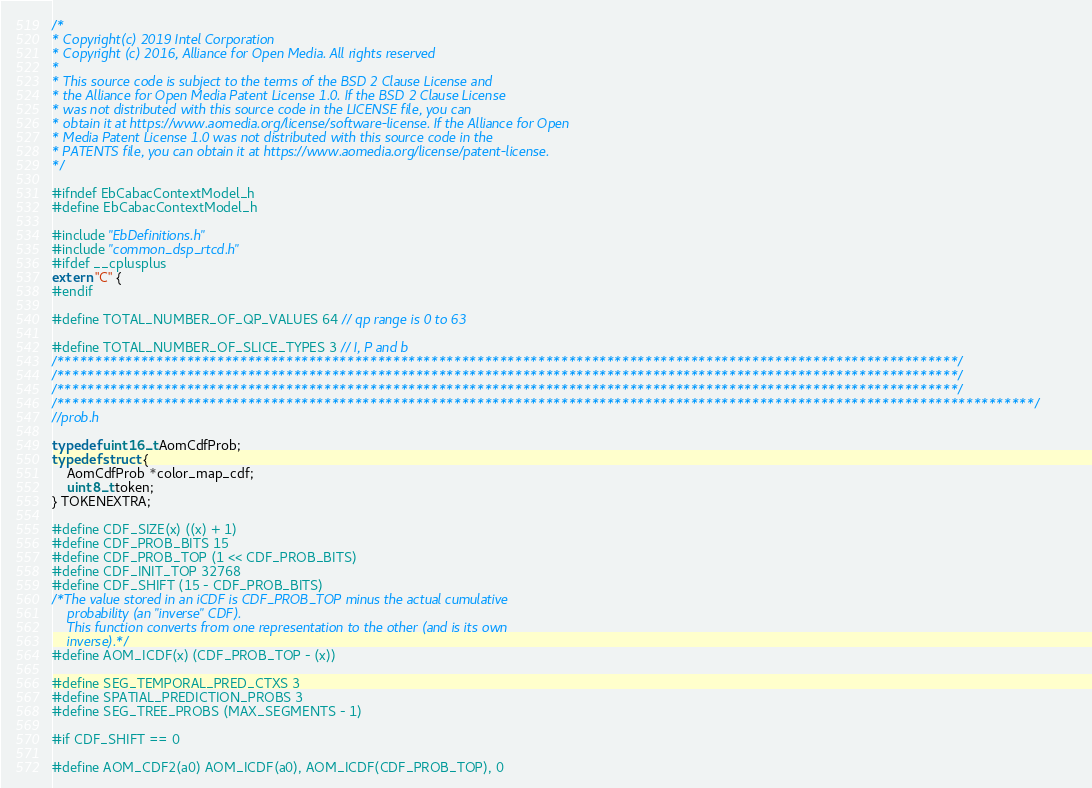<code> <loc_0><loc_0><loc_500><loc_500><_C_>/*
* Copyright(c) 2019 Intel Corporation
* Copyright (c) 2016, Alliance for Open Media. All rights reserved
*
* This source code is subject to the terms of the BSD 2 Clause License and
* the Alliance for Open Media Patent License 1.0. If the BSD 2 Clause License
* was not distributed with this source code in the LICENSE file, you can
* obtain it at https://www.aomedia.org/license/software-license. If the Alliance for Open
* Media Patent License 1.0 was not distributed with this source code in the
* PATENTS file, you can obtain it at https://www.aomedia.org/license/patent-license.
*/

#ifndef EbCabacContextModel_h
#define EbCabacContextModel_h

#include "EbDefinitions.h"
#include "common_dsp_rtcd.h"
#ifdef __cplusplus
extern "C" {
#endif

#define TOTAL_NUMBER_OF_QP_VALUES 64 // qp range is 0 to 63

#define TOTAL_NUMBER_OF_SLICE_TYPES 3 // I, P and b
/**********************************************************************************************************************/
/**********************************************************************************************************************/
/**********************************************************************************************************************/
/********************************************************************************************************************************/
//prob.h

typedef uint16_t AomCdfProb;
typedef struct {
    AomCdfProb *color_map_cdf;
    uint8_t token;
} TOKENEXTRA;

#define CDF_SIZE(x) ((x) + 1)
#define CDF_PROB_BITS 15
#define CDF_PROB_TOP (1 << CDF_PROB_BITS)
#define CDF_INIT_TOP 32768
#define CDF_SHIFT (15 - CDF_PROB_BITS)
/*The value stored in an iCDF is CDF_PROB_TOP minus the actual cumulative
    probability (an "inverse" CDF).
    This function converts from one representation to the other (and is its own
    inverse).*/
#define AOM_ICDF(x) (CDF_PROB_TOP - (x))

#define SEG_TEMPORAL_PRED_CTXS 3
#define SPATIAL_PREDICTION_PROBS 3
#define SEG_TREE_PROBS (MAX_SEGMENTS - 1)

#if CDF_SHIFT == 0

#define AOM_CDF2(a0) AOM_ICDF(a0), AOM_ICDF(CDF_PROB_TOP), 0</code> 